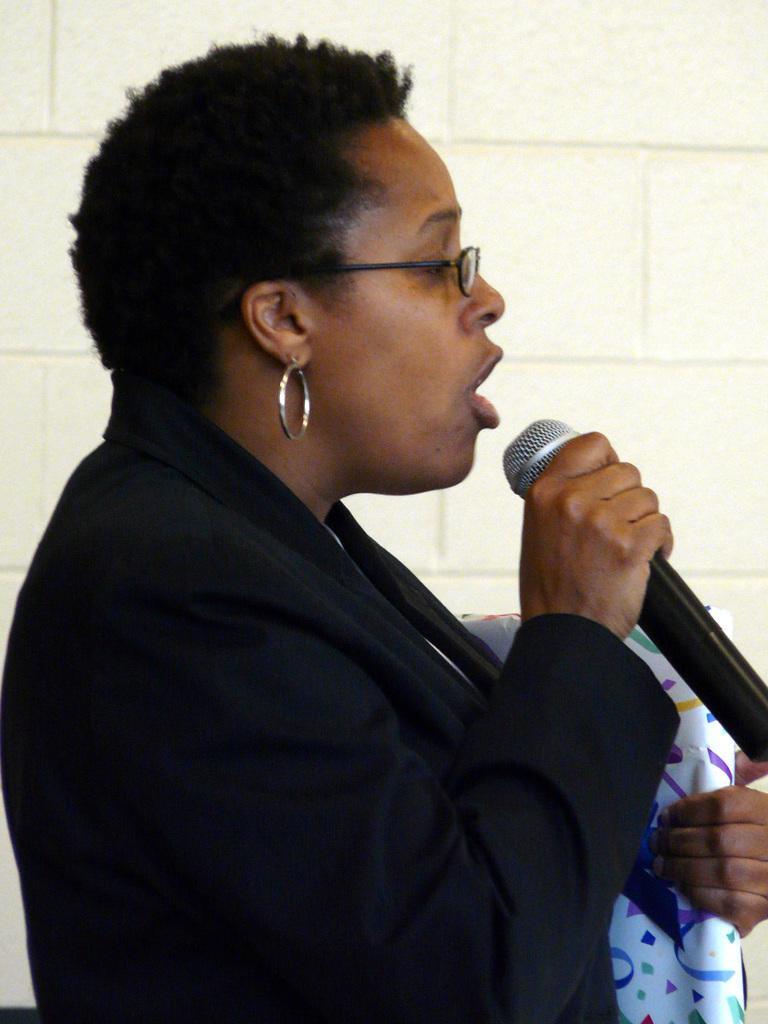In one or two sentences, can you explain what this image depicts? In this image I can see a woman in the front and I can see she is wearing a specs and black colour dress. I can also see she is holding a mic and a white colour thing. I can also see an earring on her ear and in the background I can see the wall. 